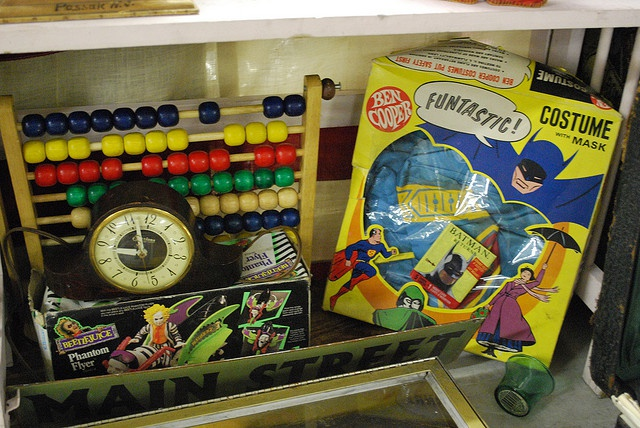Describe the objects in this image and their specific colors. I can see clock in olive, black, khaki, and tan tones and umbrella in olive, black, and gray tones in this image. 